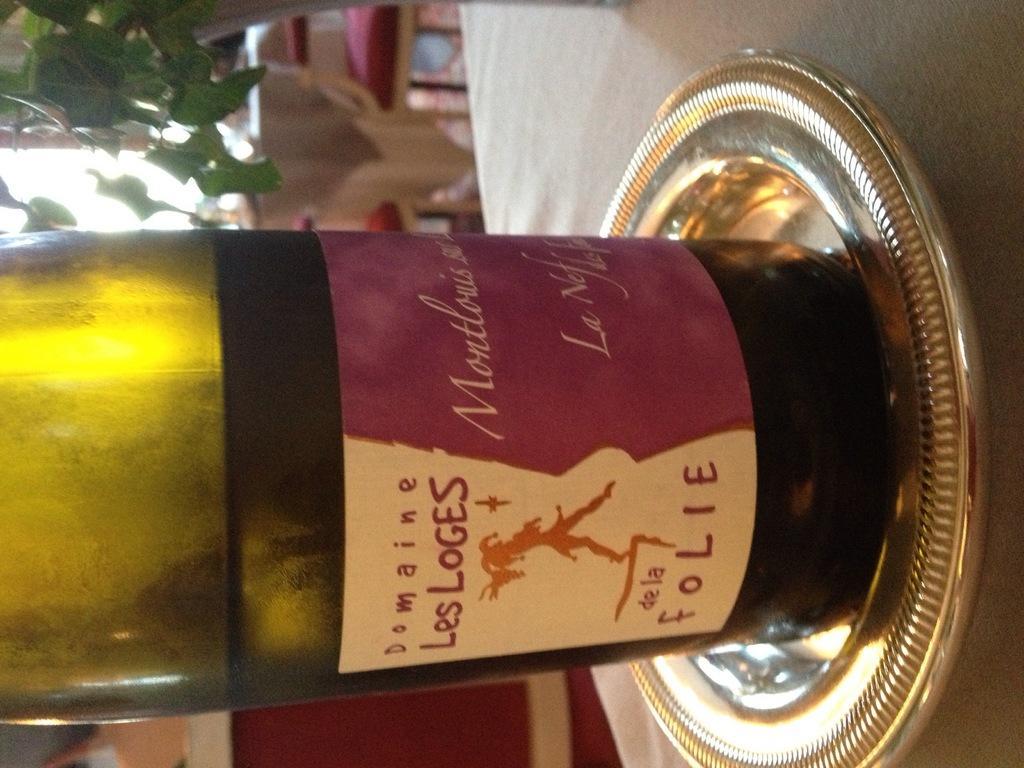Please provide a concise description of this image. In this image, a liquor bottle is kept on the table in a plate. In the left top, a house plant is visible. This image is taken inside a shop. 